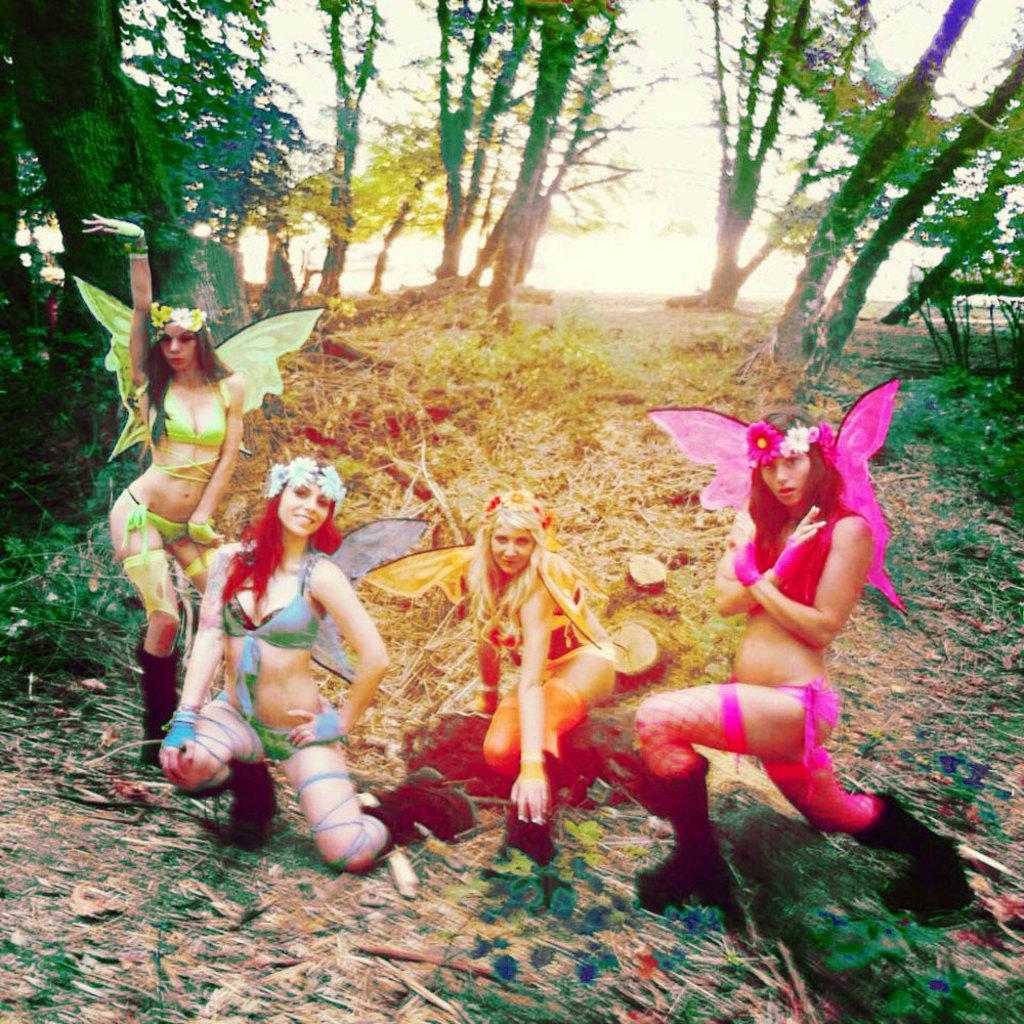In one or two sentences, can you explain what this image depicts? In this image I can see four women who are dressed in green, blue, yellow and pink in color are on the ground. I can see some grass, few trees and the ground. In the background I can see the sky. 